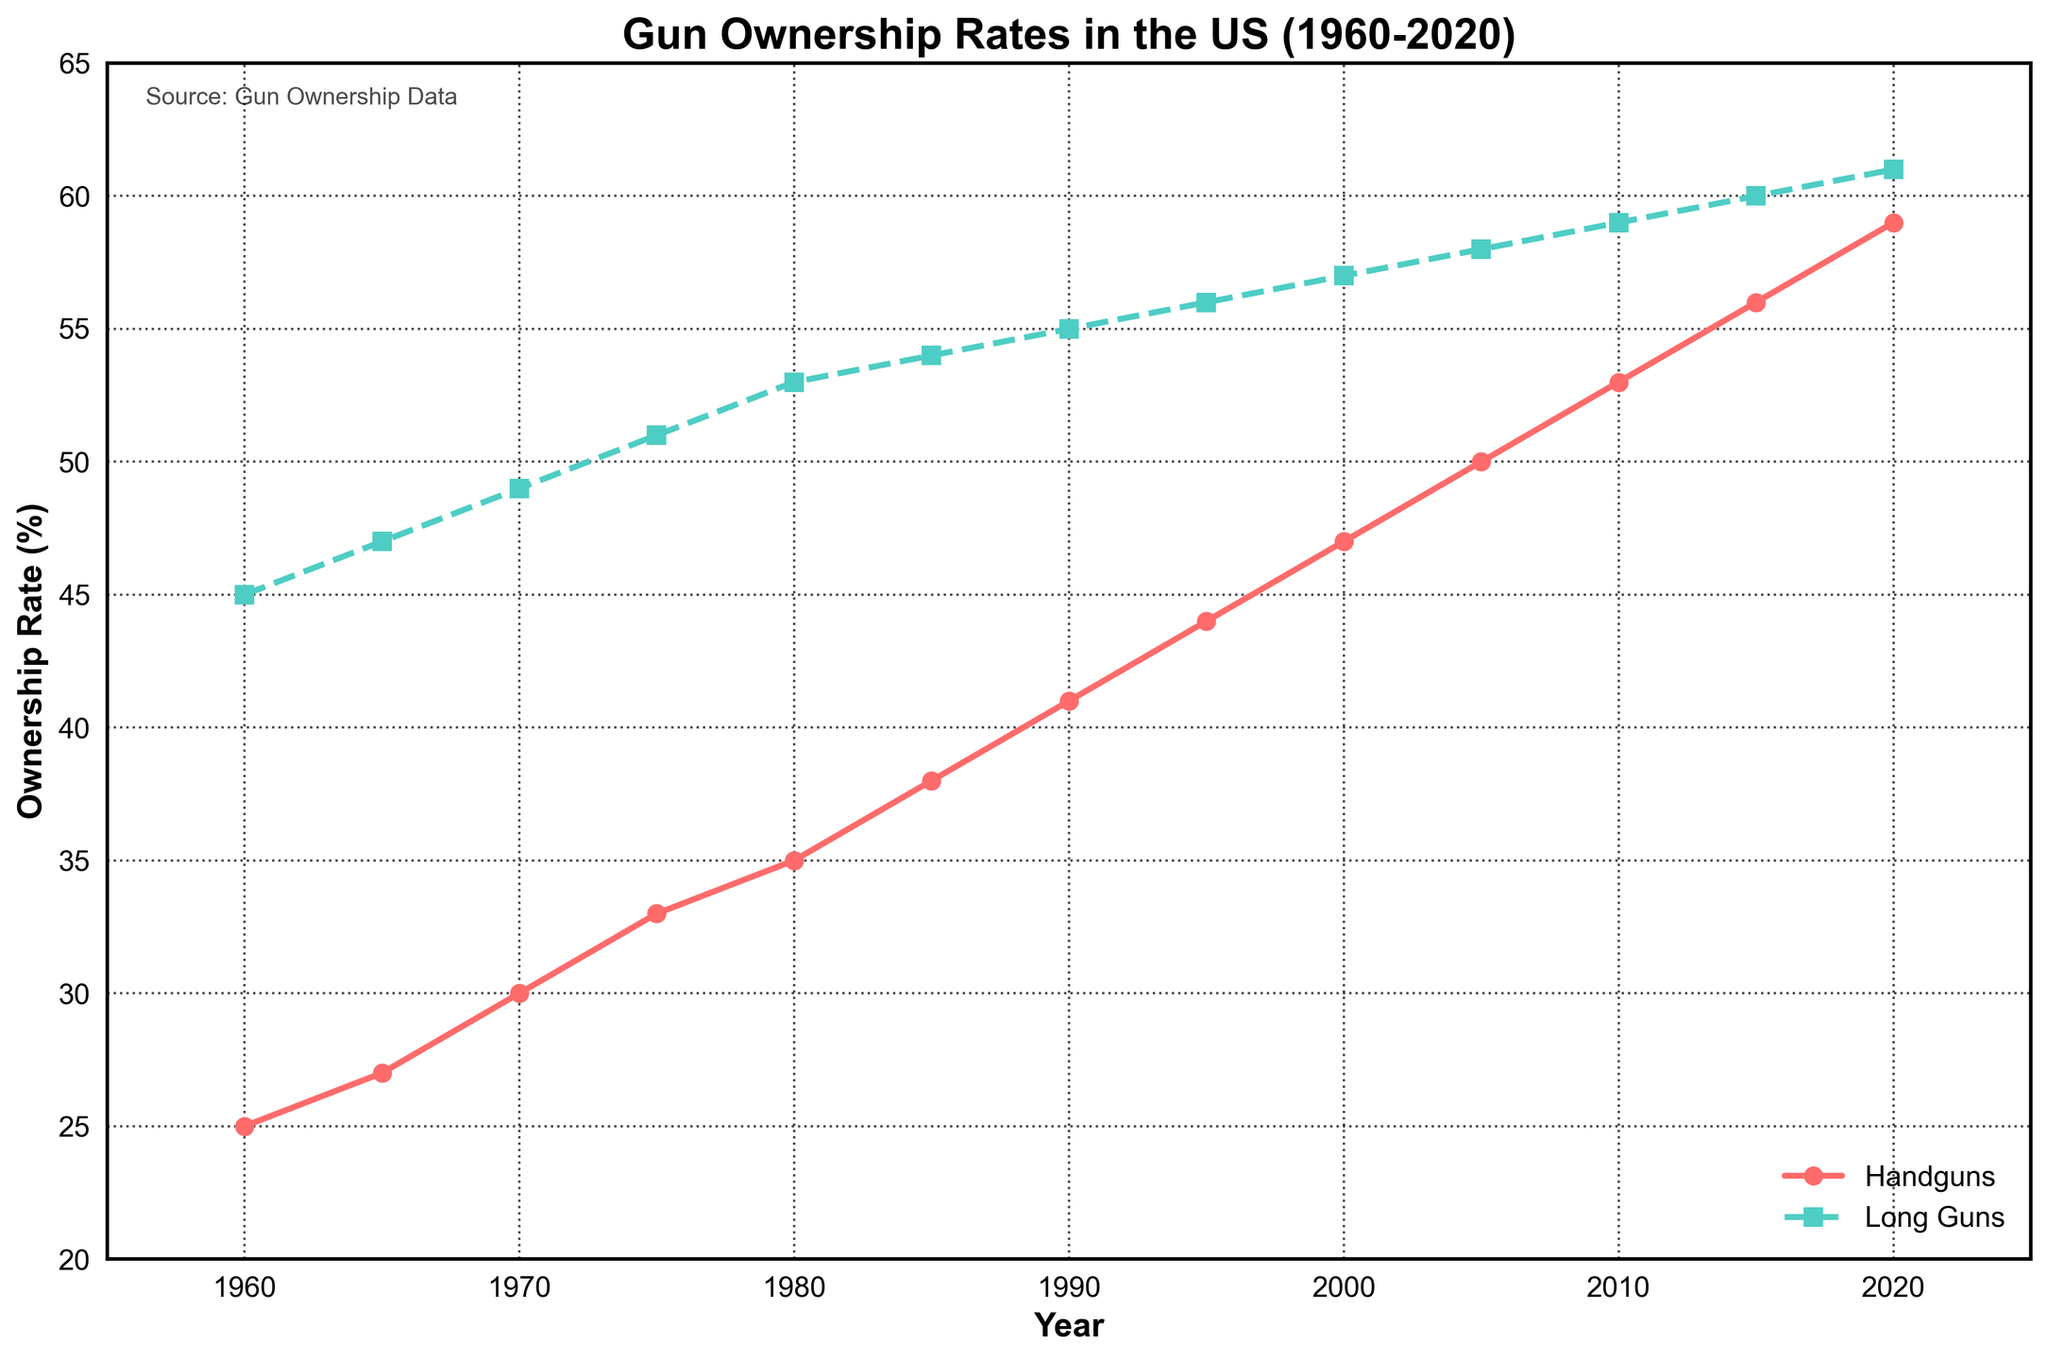What was the gun ownership rate for handguns in 1980? To determine the gun ownership rate for handguns in 1980, locate the year 1980 on the x-axis and then find the corresponding value on the y-axis for the red line (Handguns).
Answer: 35% Which type of gun had a higher ownership rate in 1990, and by how much? To compare the ownership rates in 1990, locate the year 1990 on the x-axis and find the y-values for both the red line (Handguns) and the green line (Long Guns). For 1990, Handguns have a rate of 41%, and Long Guns have a rate of 55%. The difference is 55% - 41%.
Answer: Long Guns by 14% What is the average ownership rate for handguns from 1960 to 2020? To find the average ownership rate, add the values for each year from 1960 to 2020 for handguns and then divide by the number of years. The sum is 25 + 27 + 30 + 33 + 35 + 38 + 41 + 44 + 47 + 50 + 53 + 56 + 59 = 538. There are 13 years, so the average is 538 / 13.
Answer: 41.38% In which year did both handguns and long guns have the same ownership rate trend (increase or decrease)? Both handguns and long guns are increasing in ownership rate for every year from the data provided. Locate any points where both lines move upwards.
Answer: Every year Between 2000 and 2010, which type of gun saw a greater increase in ownership rate, and by how much? Find the ownership rates for both types of guns in 2000 and 2010, then calculate the increase for each. Handguns: 53% - 47% = 6%, Long Guns: 59% - 57% = 2%. Compare the increases.
Answer: Handguns by 4% 